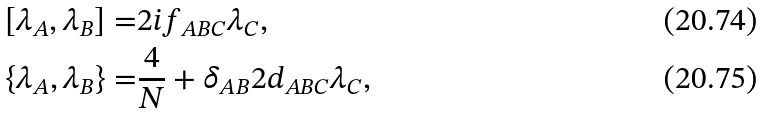Convert formula to latex. <formula><loc_0><loc_0><loc_500><loc_500>[ \lambda _ { A } , \lambda _ { B } ] = & 2 i f _ { A B C } \lambda _ { C } , \\ \{ \lambda _ { A } , \lambda _ { B } \} = & \frac { 4 } { N } + \delta _ { A B } 2 d _ { A B C } \lambda _ { C } ,</formula> 